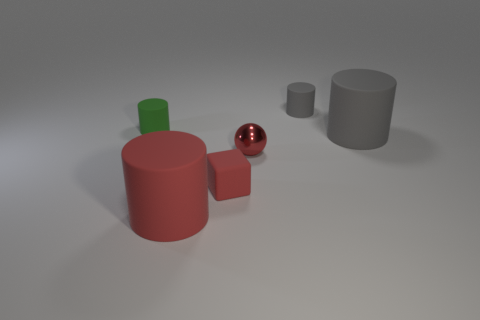Subtract all cyan balls. How many gray cylinders are left? 2 Subtract all red matte cylinders. How many cylinders are left? 3 Subtract all red cylinders. How many cylinders are left? 3 Add 2 green cylinders. How many objects exist? 8 Subtract all brown cylinders. Subtract all red cubes. How many cylinders are left? 4 Subtract all cylinders. How many objects are left? 2 Subtract 0 yellow cubes. How many objects are left? 6 Subtract all purple blocks. Subtract all matte objects. How many objects are left? 1 Add 2 red cylinders. How many red cylinders are left? 3 Add 4 big gray blocks. How many big gray blocks exist? 4 